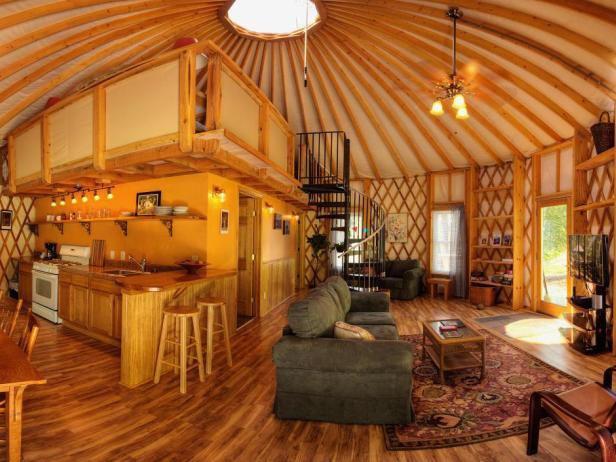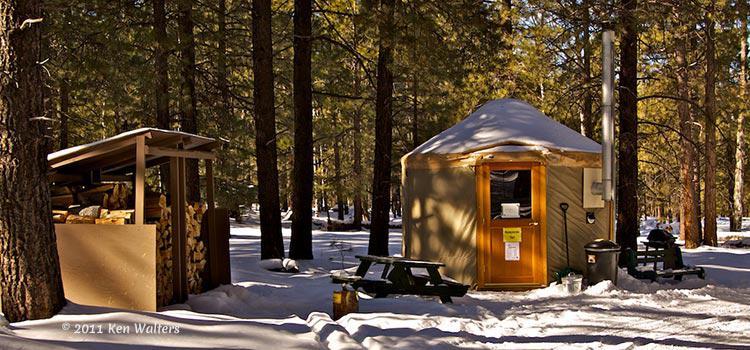The first image is the image on the left, the second image is the image on the right. Analyze the images presented: Is the assertion "Each image shows the snowy winter exterior of a yurt, with decking of wooden posts and railings." valid? Answer yes or no. No. The first image is the image on the left, the second image is the image on the right. Given the left and right images, does the statement "An image shows a round structure surrounded by a round railed deck, and the structure has lattice-work showing in the windows." hold true? Answer yes or no. No. 